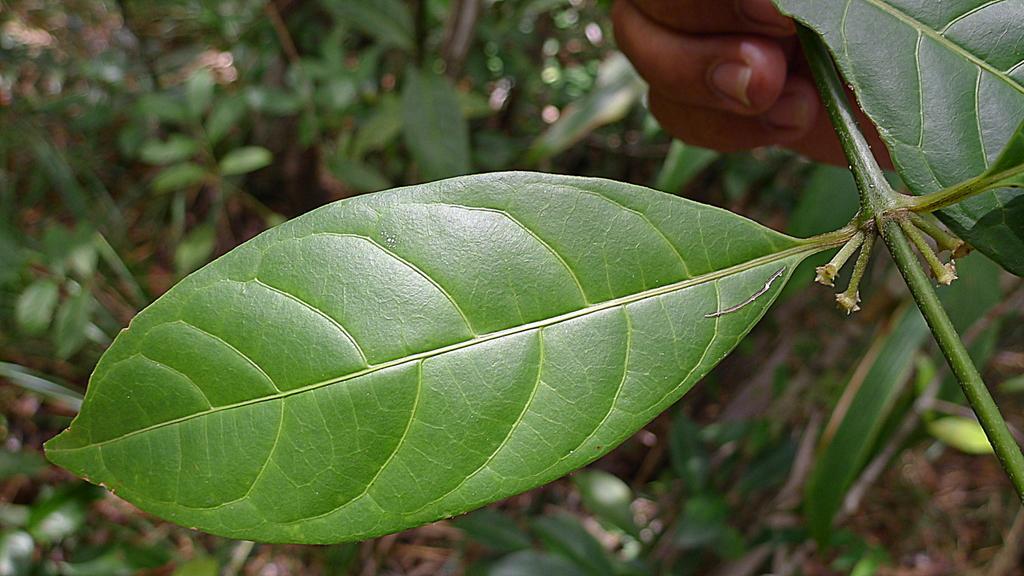Could you give a brief overview of what you see in this image? In this image we can see a leaf. Here we can see a person's hand holding the plant. The background of the image is blurred, where we can see plants. 